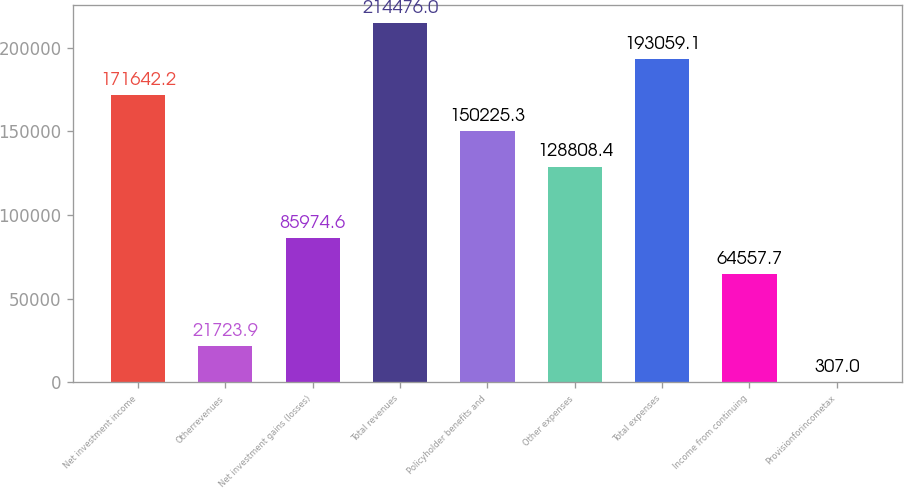Convert chart. <chart><loc_0><loc_0><loc_500><loc_500><bar_chart><fcel>Net investment income<fcel>Otherrevenues<fcel>Net investment gains (losses)<fcel>Total revenues<fcel>Policyholder benefits and<fcel>Other expenses<fcel>Total expenses<fcel>Income from continuing<fcel>Provisionforincometax<nl><fcel>171642<fcel>21723.9<fcel>85974.6<fcel>214476<fcel>150225<fcel>128808<fcel>193059<fcel>64557.7<fcel>307<nl></chart> 